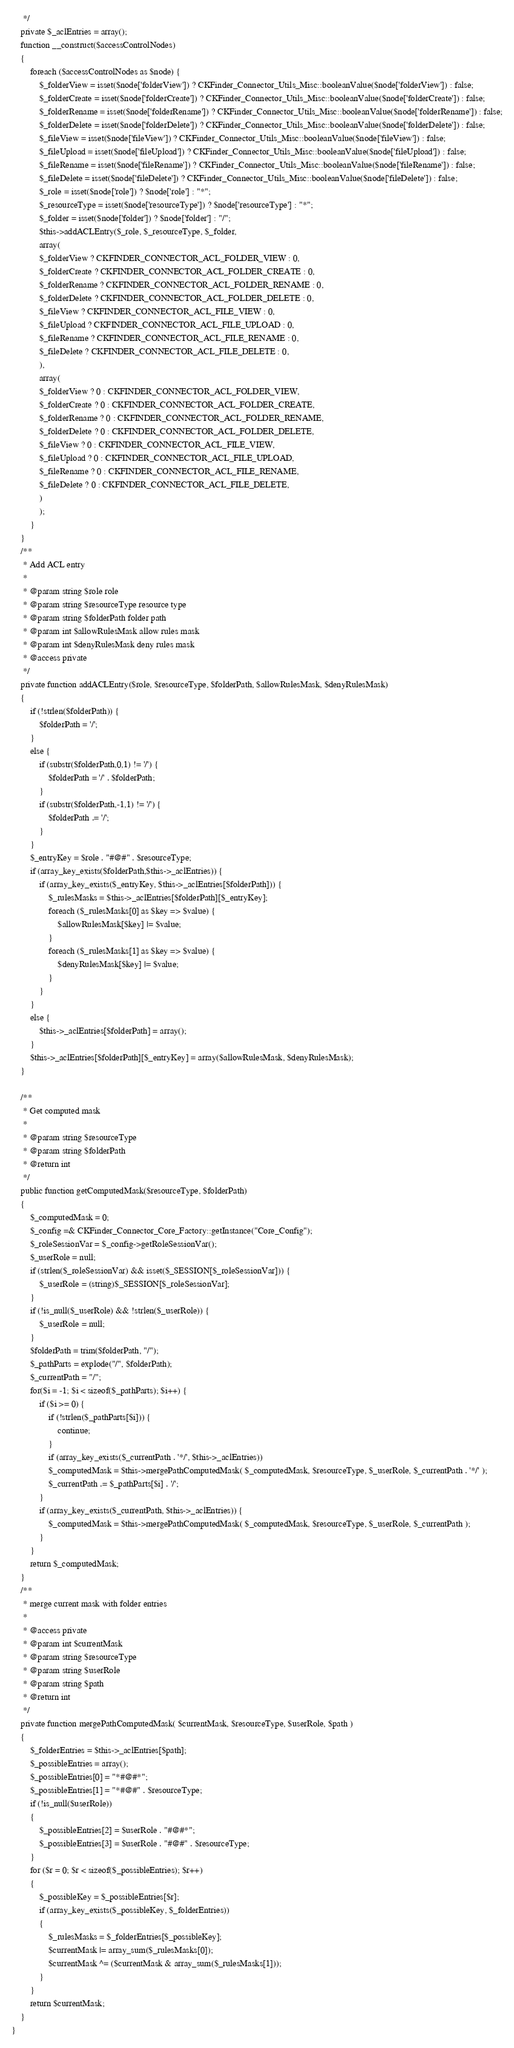<code> <loc_0><loc_0><loc_500><loc_500><_PHP_>     */
    private $_aclEntries = array();
    function __construct($accessControlNodes)
    {
        foreach ($accessControlNodes as $node) {
            $_folderView = isset($node['folderView']) ? CKFinder_Connector_Utils_Misc::booleanValue($node['folderView']) : false;
            $_folderCreate = isset($node['folderCreate']) ? CKFinder_Connector_Utils_Misc::booleanValue($node['folderCreate']) : false;
            $_folderRename = isset($node['folderRename']) ? CKFinder_Connector_Utils_Misc::booleanValue($node['folderRename']) : false;
            $_folderDelete = isset($node['folderDelete']) ? CKFinder_Connector_Utils_Misc::booleanValue($node['folderDelete']) : false;
            $_fileView = isset($node['fileView']) ? CKFinder_Connector_Utils_Misc::booleanValue($node['fileView']) : false;
            $_fileUpload = isset($node['fileUpload']) ? CKFinder_Connector_Utils_Misc::booleanValue($node['fileUpload']) : false;
            $_fileRename = isset($node['fileRename']) ? CKFinder_Connector_Utils_Misc::booleanValue($node['fileRename']) : false;
            $_fileDelete = isset($node['fileDelete']) ? CKFinder_Connector_Utils_Misc::booleanValue($node['fileDelete']) : false;
            $_role = isset($node['role']) ? $node['role'] : "*";
            $_resourceType = isset($node['resourceType']) ? $node['resourceType'] : "*";
            $_folder = isset($node['folder']) ? $node['folder'] : "/";
            $this->addACLEntry($_role, $_resourceType, $_folder,
            array(
            $_folderView ? CKFINDER_CONNECTOR_ACL_FOLDER_VIEW : 0,
            $_folderCreate ? CKFINDER_CONNECTOR_ACL_FOLDER_CREATE : 0,
            $_folderRename ? CKFINDER_CONNECTOR_ACL_FOLDER_RENAME : 0,
            $_folderDelete ? CKFINDER_CONNECTOR_ACL_FOLDER_DELETE : 0,
            $_fileView ? CKFINDER_CONNECTOR_ACL_FILE_VIEW : 0,
            $_fileUpload ? CKFINDER_CONNECTOR_ACL_FILE_UPLOAD : 0,
            $_fileRename ? CKFINDER_CONNECTOR_ACL_FILE_RENAME : 0,
            $_fileDelete ? CKFINDER_CONNECTOR_ACL_FILE_DELETE : 0,
            ),
            array(
            $_folderView ? 0 : CKFINDER_CONNECTOR_ACL_FOLDER_VIEW,
            $_folderCreate ? 0 : CKFINDER_CONNECTOR_ACL_FOLDER_CREATE,
            $_folderRename ? 0 : CKFINDER_CONNECTOR_ACL_FOLDER_RENAME,
            $_folderDelete ? 0 : CKFINDER_CONNECTOR_ACL_FOLDER_DELETE,
            $_fileView ? 0 : CKFINDER_CONNECTOR_ACL_FILE_VIEW,
            $_fileUpload ? 0 : CKFINDER_CONNECTOR_ACL_FILE_UPLOAD,
            $_fileRename ? 0 : CKFINDER_CONNECTOR_ACL_FILE_RENAME,
            $_fileDelete ? 0 : CKFINDER_CONNECTOR_ACL_FILE_DELETE,
            )
            );
        }
    }
    /**
     * Add ACL entry
     *
     * @param string $role role
     * @param string $resourceType resource type
     * @param string $folderPath folder path
     * @param int $allowRulesMask allow rules mask
     * @param int $denyRulesMask deny rules mask
     * @access private
     */
    private function addACLEntry($role, $resourceType, $folderPath, $allowRulesMask, $denyRulesMask)
    {
        if (!strlen($folderPath)) {
            $folderPath = '/';
        }
        else {
            if (substr($folderPath,0,1) != '/') {
                $folderPath = '/' . $folderPath;
            }
            if (substr($folderPath,-1,1) != '/') {
                $folderPath .= '/';
            }
        }
        $_entryKey = $role . "#@#" . $resourceType;
        if (array_key_exists($folderPath,$this->_aclEntries)) {
            if (array_key_exists($_entryKey, $this->_aclEntries[$folderPath])) {
                $_rulesMasks = $this->_aclEntries[$folderPath][$_entryKey];
                foreach ($_rulesMasks[0] as $key => $value) {
                    $allowRulesMask[$key] |= $value;
                }
                foreach ($_rulesMasks[1] as $key => $value) {
                    $denyRulesMask[$key] |= $value;
                }
            }
        }
        else {
            $this->_aclEntries[$folderPath] = array();
        }
        $this->_aclEntries[$folderPath][$_entryKey] = array($allowRulesMask, $denyRulesMask);
    }

    /**
     * Get computed mask
     *
     * @param string $resourceType
     * @param string $folderPath
     * @return int
     */
    public function getComputedMask($resourceType, $folderPath)
    {
        $_computedMask = 0;
        $_config =& CKFinder_Connector_Core_Factory::getInstance("Core_Config");
        $_roleSessionVar = $_config->getRoleSessionVar();
        $_userRole = null;
        if (strlen($_roleSessionVar) && isset($_SESSION[$_roleSessionVar])) {
            $_userRole = (string)$_SESSION[$_roleSessionVar];
        }
        if (!is_null($_userRole) && !strlen($_userRole)) {
            $_userRole = null;
        }
        $folderPath = trim($folderPath, "/");
        $_pathParts = explode("/", $folderPath);
        $_currentPath = "/";
        for($i = -1; $i < sizeof($_pathParts); $i++) {
            if ($i >= 0) {
                if (!strlen($_pathParts[$i])) {
                    continue;
                }
                if (array_key_exists($_currentPath . '*/', $this->_aclEntries))
                $_computedMask = $this->mergePathComputedMask( $_computedMask, $resourceType, $_userRole, $_currentPath . '*/' );
                $_currentPath .= $_pathParts[$i] . '/';
            }
            if (array_key_exists($_currentPath, $this->_aclEntries)) {
                $_computedMask = $this->mergePathComputedMask( $_computedMask, $resourceType, $_userRole, $_currentPath );
            }
        }
        return $_computedMask;
    }
    /**
     * merge current mask with folder entries
     *
     * @access private
     * @param int $currentMask
     * @param string $resourceType
     * @param string $userRole
     * @param string $path
     * @return int
     */
    private function mergePathComputedMask( $currentMask, $resourceType, $userRole, $path )
    {
        $_folderEntries = $this->_aclEntries[$path];
        $_possibleEntries = array();
        $_possibleEntries[0] = "*#@#*";
        $_possibleEntries[1] = "*#@#" . $resourceType;
        if (!is_null($userRole))
        {
            $_possibleEntries[2] = $userRole . "#@#*";
            $_possibleEntries[3] = $userRole . "#@#" . $resourceType;
        }
        for ($r = 0; $r < sizeof($_possibleEntries); $r++)
        {
            $_possibleKey = $_possibleEntries[$r];
            if (array_key_exists($_possibleKey, $_folderEntries))
            {
                $_rulesMasks = $_folderEntries[$_possibleKey];
                $currentMask |= array_sum($_rulesMasks[0]);
                $currentMask ^= ($currentMask & array_sum($_rulesMasks[1]));
            }
        }
        return $currentMask;
    }
}
</code> 